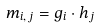<formula> <loc_0><loc_0><loc_500><loc_500>m _ { i , \, j } = g _ { i } \cdot h _ { j }</formula> 